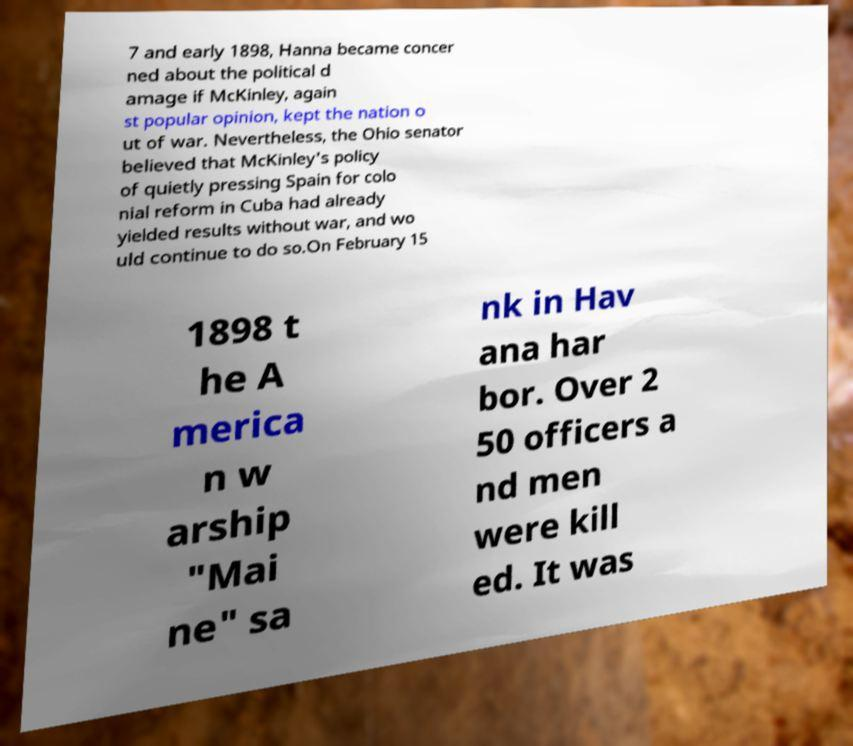Please read and relay the text visible in this image. What does it say? 7 and early 1898, Hanna became concer ned about the political d amage if McKinley, again st popular opinion, kept the nation o ut of war. Nevertheless, the Ohio senator believed that McKinley's policy of quietly pressing Spain for colo nial reform in Cuba had already yielded results without war, and wo uld continue to do so.On February 15 1898 t he A merica n w arship "Mai ne" sa nk in Hav ana har bor. Over 2 50 officers a nd men were kill ed. It was 